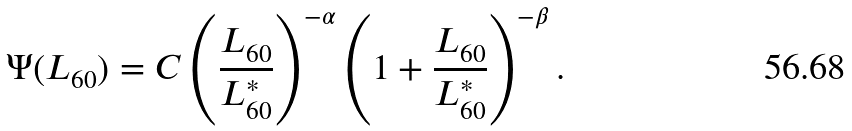Convert formula to latex. <formula><loc_0><loc_0><loc_500><loc_500>\Psi ( L _ { 6 0 } ) = C \left ( \frac { L _ { 6 0 } } { L _ { 6 0 } ^ { * } } \right ) ^ { - \alpha } \left ( 1 + \frac { L _ { 6 0 } } { L _ { 6 0 } ^ { * } } \right ) ^ { - \beta } .</formula> 